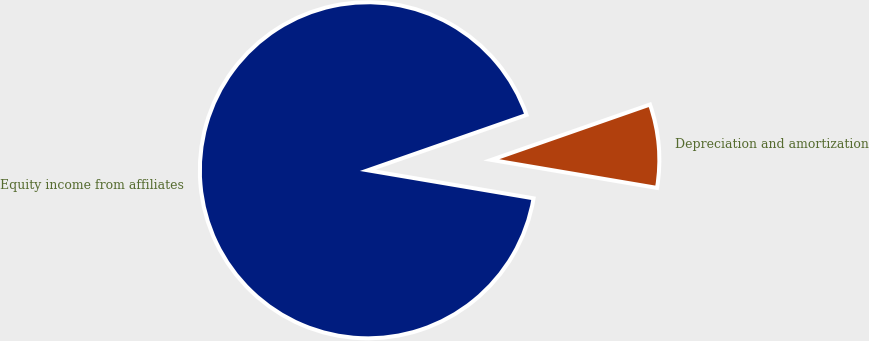Convert chart to OTSL. <chart><loc_0><loc_0><loc_500><loc_500><pie_chart><fcel>Equity income from affiliates<fcel>Depreciation and amortization<nl><fcel>91.99%<fcel>8.01%<nl></chart> 